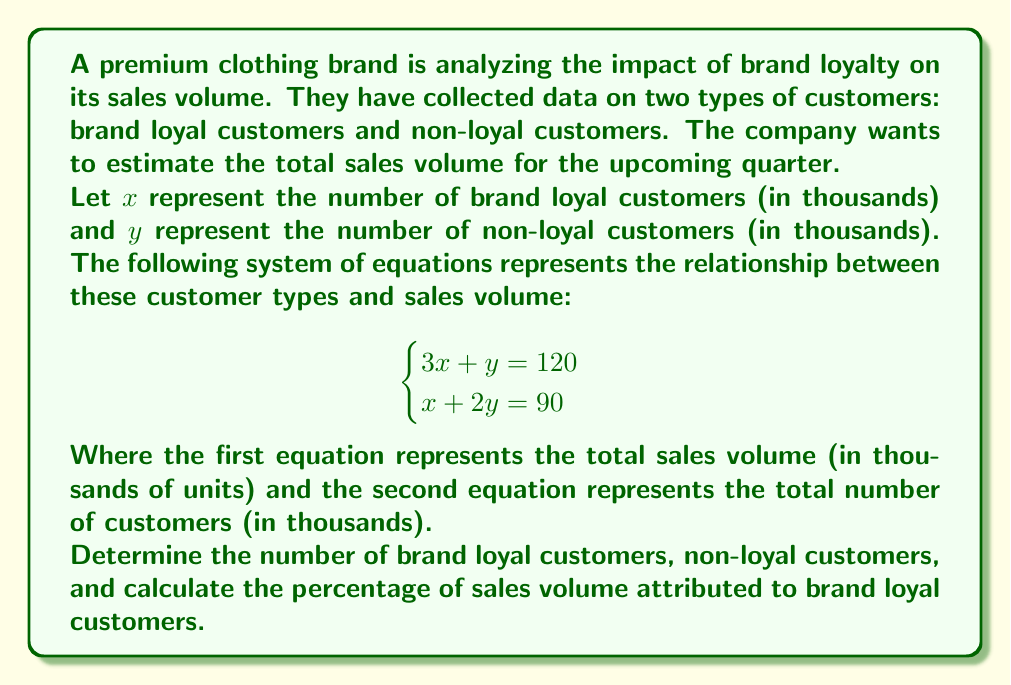Show me your answer to this math problem. To solve this problem, we'll use the substitution method:

1. From the second equation, express $x$ in terms of $y$:
   $x + 2y = 90$
   $x = 90 - 2y$

2. Substitute this expression for $x$ into the first equation:
   $3(90 - 2y) + y = 120$
   $270 - 6y + y = 120$
   $270 - 5y = 120$

3. Solve for $y$:
   $-5y = -150$
   $y = 30$

4. Substitute $y = 30$ back into the equation from step 1 to find $x$:
   $x = 90 - 2(30) = 30$

5. Now we know that $x = 30$ (30,000 brand loyal customers) and $y = 30$ (30,000 non-loyal customers).

6. To calculate the sales volume attributed to brand loyal customers, use the first equation:
   $3x + y = 120$
   Brand loyal customers contribute: $3x = 3(30) = 90$ thousand units
   Total sales volume: 120 thousand units

7. Calculate the percentage:
   Percentage = (Sales from loyal customers / Total sales) × 100
   $= (90 / 120) × 100 = 75\%$
Answer: Brand loyal customers: 30,000
Non-loyal customers: 30,000
Percentage of sales volume attributed to brand loyal customers: 75% 